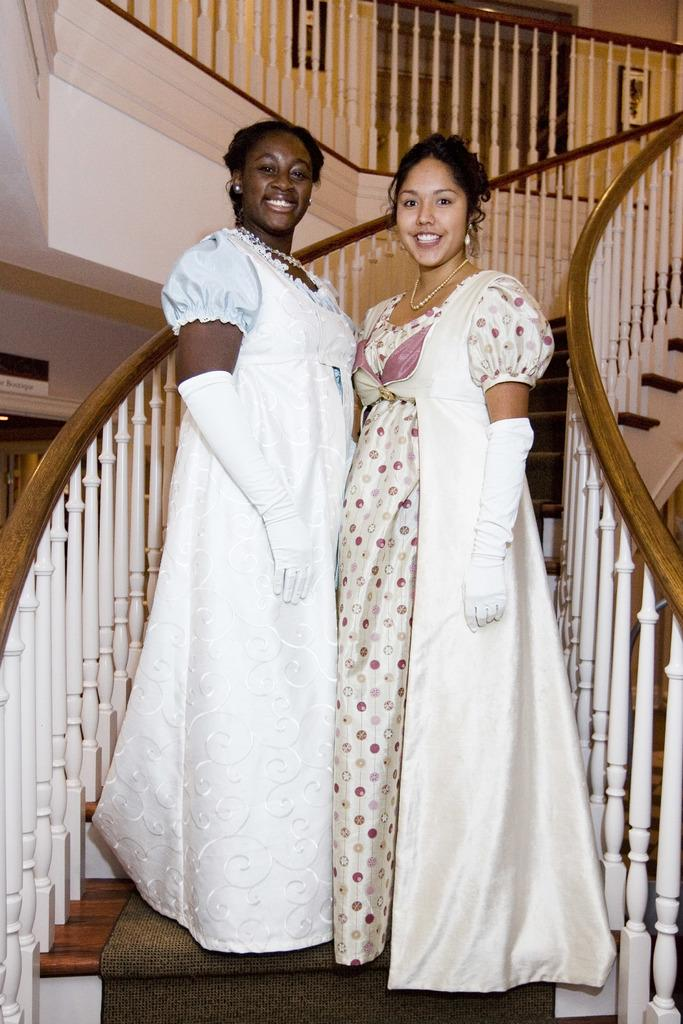How many people are standing on steps in the image? There are two people standing on steps in the image. What can be seen in the background of the image? In the background of the image, there are railings, pictures, a board, additional steps, and a wall. What might the railings be used for? The railings might be used for support or safety while walking on the steps. What is the purpose of the board in the background of the image? The purpose of the board in the background of the image is not clear from the facts provided. What type of tin can be seen being used for teaching in the image? There is no tin present in the image, nor is there any indication of teaching taking place. 